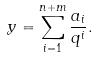Convert formula to latex. <formula><loc_0><loc_0><loc_500><loc_500>y = \sum _ { i = 1 } ^ { n + m } \frac { a _ { i } } { q ^ { i } } .</formula> 